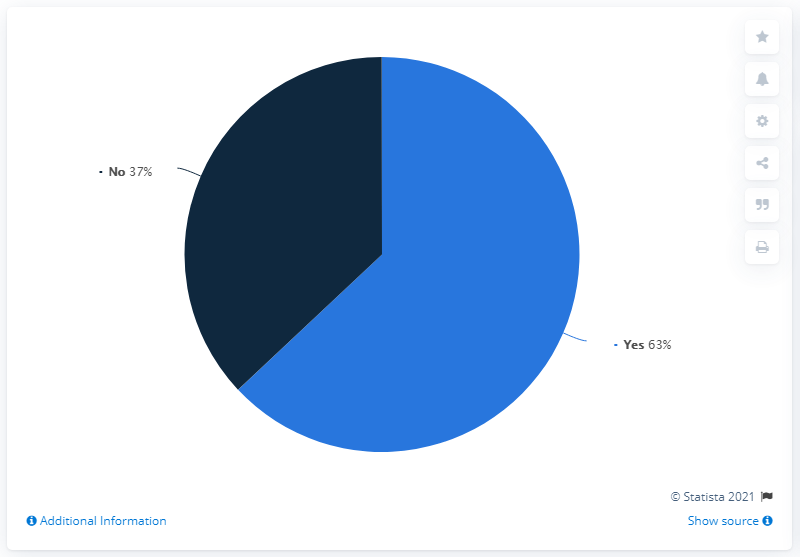Draw attention to some important aspects in this diagram. The pie chart uses two colors to represent its slices. The product of the largest segment and the average of all the segments is 3150. 